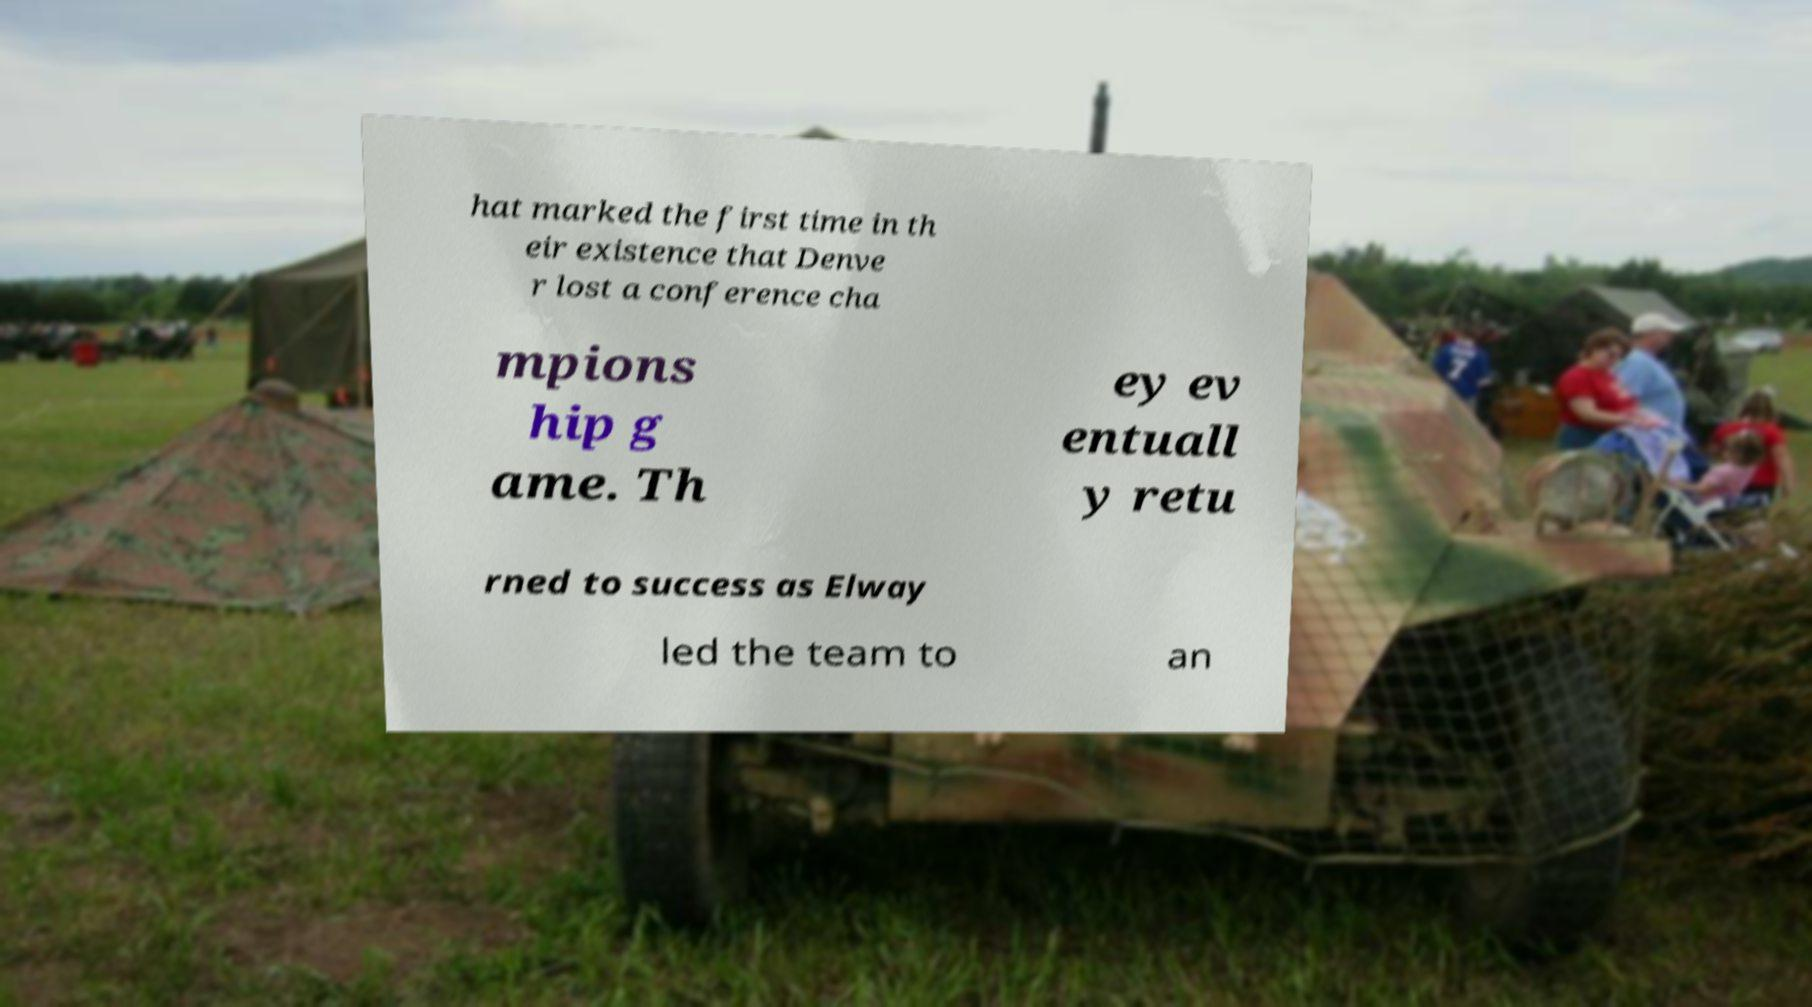Can you accurately transcribe the text from the provided image for me? hat marked the first time in th eir existence that Denve r lost a conference cha mpions hip g ame. Th ey ev entuall y retu rned to success as Elway led the team to an 